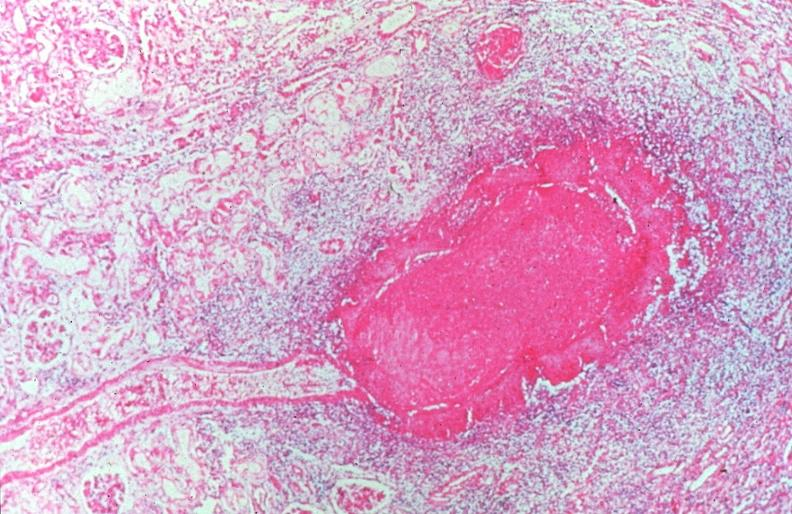s vasculature present?
Answer the question using a single word or phrase. Yes 